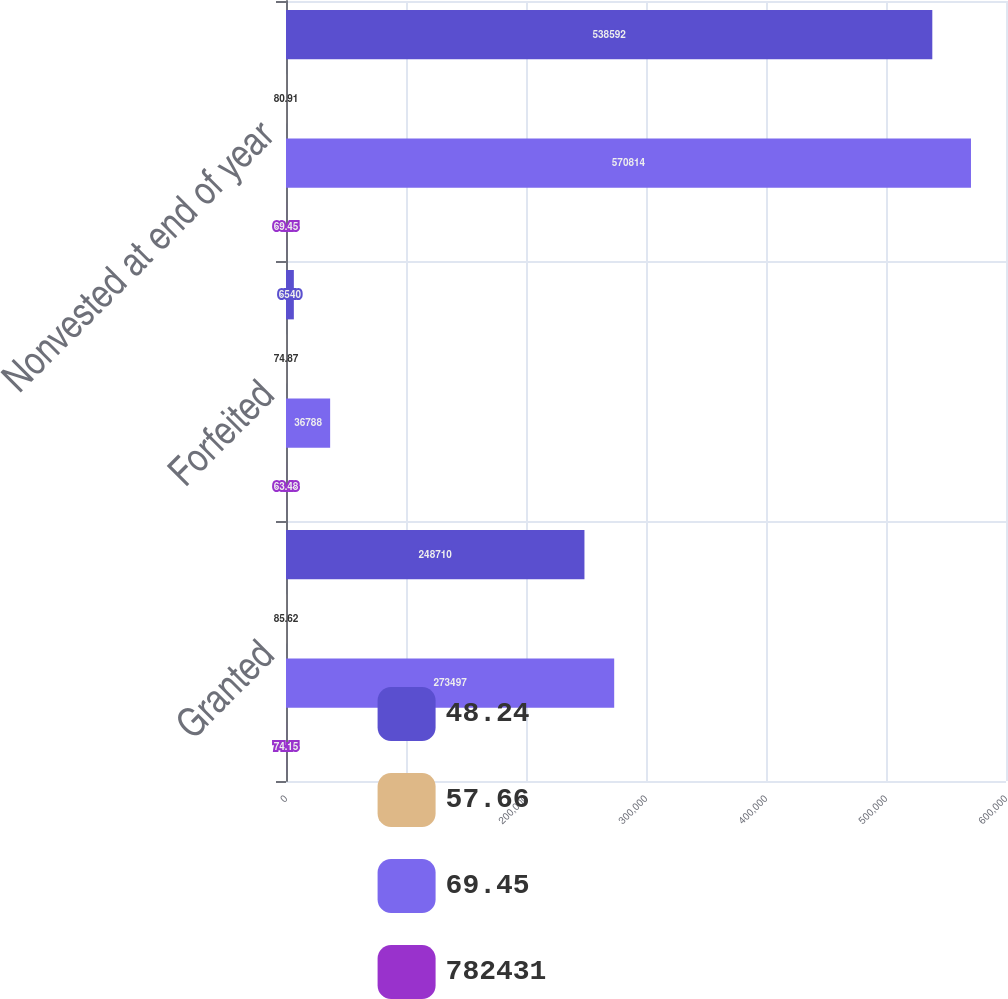Convert chart to OTSL. <chart><loc_0><loc_0><loc_500><loc_500><stacked_bar_chart><ecel><fcel>Granted<fcel>Forfeited<fcel>Nonvested at end of year<nl><fcel>48.24<fcel>248710<fcel>6540<fcel>538592<nl><fcel>57.66<fcel>85.62<fcel>74.87<fcel>80.91<nl><fcel>69.45<fcel>273497<fcel>36788<fcel>570814<nl><fcel>782431<fcel>74.15<fcel>63.48<fcel>69.45<nl></chart> 